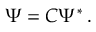Convert formula to latex. <formula><loc_0><loc_0><loc_500><loc_500>\Psi = { C } \Psi ^ { \ast } \, .</formula> 